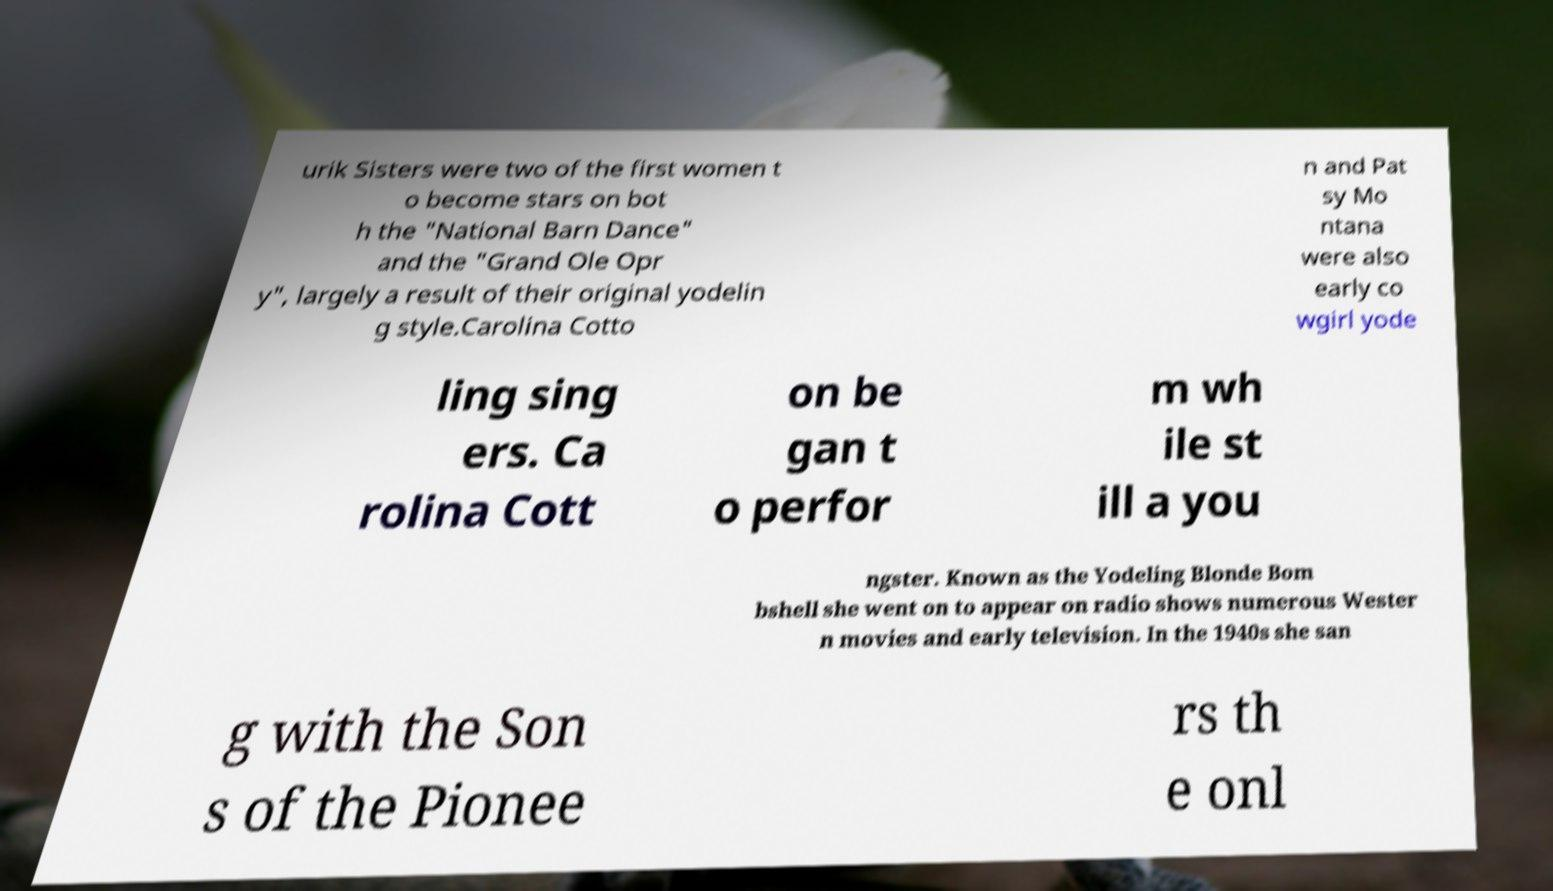Could you assist in decoding the text presented in this image and type it out clearly? urik Sisters were two of the first women t o become stars on bot h the "National Barn Dance" and the "Grand Ole Opr y", largely a result of their original yodelin g style.Carolina Cotto n and Pat sy Mo ntana were also early co wgirl yode ling sing ers. Ca rolina Cott on be gan t o perfor m wh ile st ill a you ngster. Known as the Yodeling Blonde Bom bshell she went on to appear on radio shows numerous Wester n movies and early television. In the 1940s she san g with the Son s of the Pionee rs th e onl 